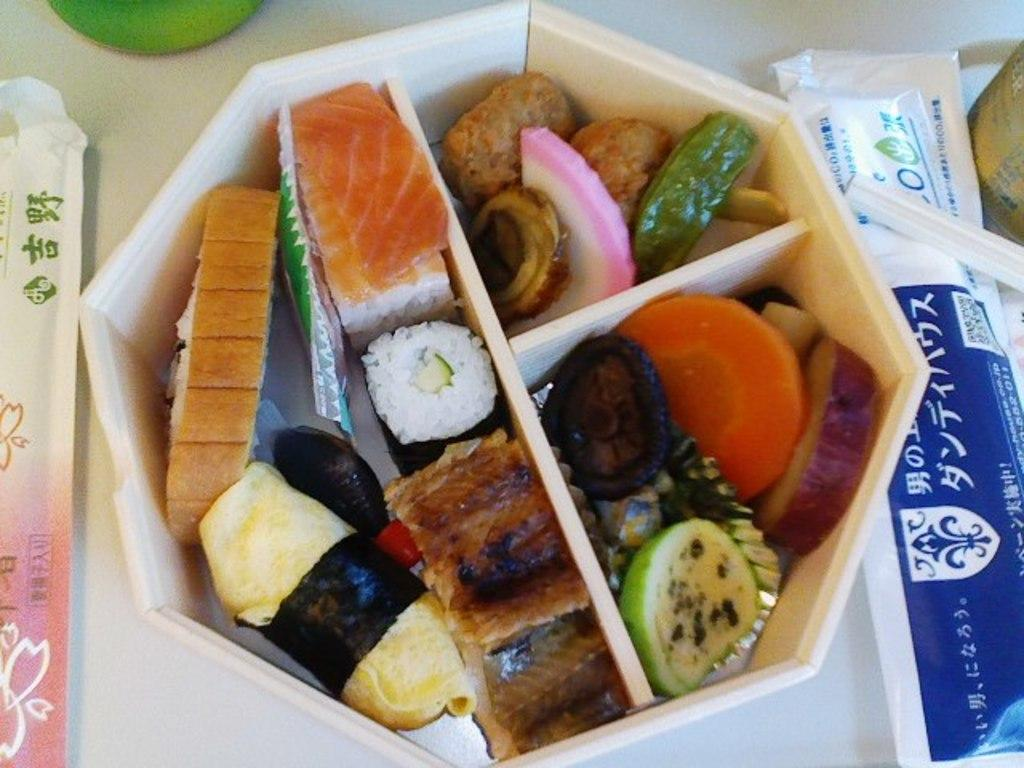What is inside the box that is visible in the image? There are food items in a box in the image. What else can be seen on the surface in the image? There are packets and other objects on the surface in the image. How many sisters are present in the image? There is no mention of sisters in the image, as the facts provided only discuss food items, packets, and other objects on a surface. What type of clam can be seen in the image? There is no clam present in the image. 